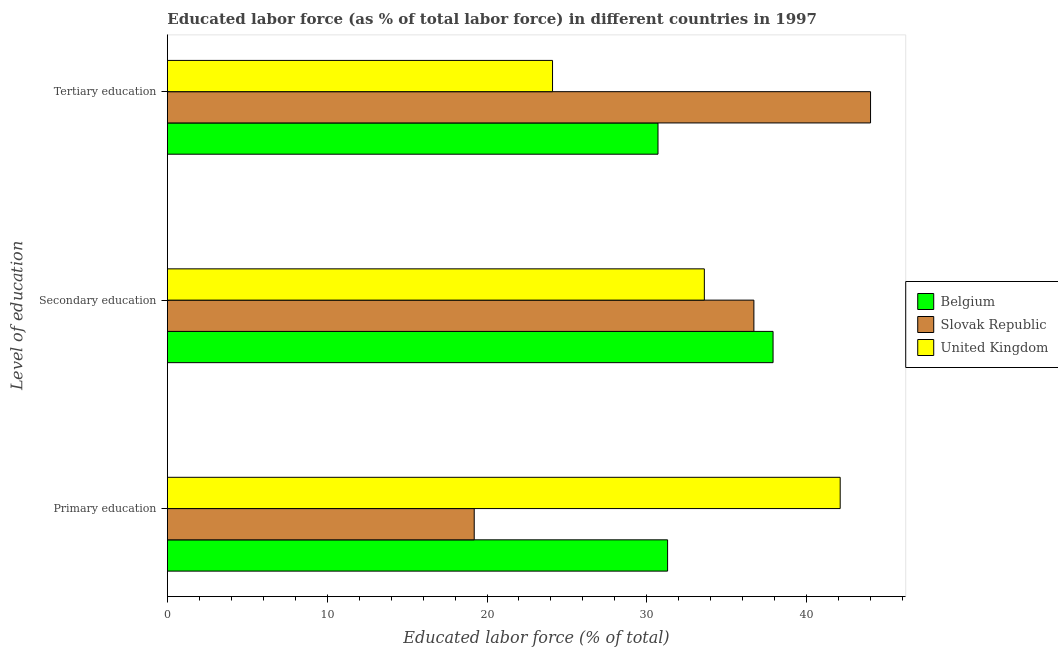Are the number of bars per tick equal to the number of legend labels?
Give a very brief answer. Yes. Are the number of bars on each tick of the Y-axis equal?
Your answer should be compact. Yes. How many bars are there on the 2nd tick from the top?
Ensure brevity in your answer.  3. How many bars are there on the 2nd tick from the bottom?
Keep it short and to the point. 3. What is the percentage of labor force who received tertiary education in Belgium?
Keep it short and to the point. 30.7. Across all countries, what is the minimum percentage of labor force who received secondary education?
Offer a very short reply. 33.6. In which country was the percentage of labor force who received tertiary education maximum?
Offer a very short reply. Slovak Republic. In which country was the percentage of labor force who received secondary education minimum?
Your answer should be compact. United Kingdom. What is the total percentage of labor force who received secondary education in the graph?
Make the answer very short. 108.2. What is the difference between the percentage of labor force who received primary education in Belgium and that in United Kingdom?
Provide a succinct answer. -10.8. What is the difference between the percentage of labor force who received primary education in Belgium and the percentage of labor force who received tertiary education in Slovak Republic?
Provide a short and direct response. -12.7. What is the average percentage of labor force who received tertiary education per country?
Provide a succinct answer. 32.93. What is the difference between the percentage of labor force who received secondary education and percentage of labor force who received tertiary education in Slovak Republic?
Your answer should be compact. -7.3. In how many countries, is the percentage of labor force who received tertiary education greater than 24 %?
Provide a short and direct response. 3. What is the ratio of the percentage of labor force who received tertiary education in United Kingdom to that in Slovak Republic?
Give a very brief answer. 0.55. Is the percentage of labor force who received tertiary education in Slovak Republic less than that in United Kingdom?
Keep it short and to the point. No. Is the difference between the percentage of labor force who received secondary education in Belgium and United Kingdom greater than the difference between the percentage of labor force who received primary education in Belgium and United Kingdom?
Keep it short and to the point. Yes. What is the difference between the highest and the second highest percentage of labor force who received primary education?
Keep it short and to the point. 10.8. What is the difference between the highest and the lowest percentage of labor force who received secondary education?
Your answer should be compact. 4.3. What does the 1st bar from the top in Primary education represents?
Give a very brief answer. United Kingdom. What does the 2nd bar from the bottom in Tertiary education represents?
Your answer should be compact. Slovak Republic. How many bars are there?
Ensure brevity in your answer.  9. Are all the bars in the graph horizontal?
Your response must be concise. Yes. How many countries are there in the graph?
Ensure brevity in your answer.  3. Are the values on the major ticks of X-axis written in scientific E-notation?
Keep it short and to the point. No. Does the graph contain grids?
Offer a terse response. No. Where does the legend appear in the graph?
Make the answer very short. Center right. What is the title of the graph?
Your response must be concise. Educated labor force (as % of total labor force) in different countries in 1997. Does "St. Lucia" appear as one of the legend labels in the graph?
Keep it short and to the point. No. What is the label or title of the X-axis?
Provide a succinct answer. Educated labor force (% of total). What is the label or title of the Y-axis?
Your response must be concise. Level of education. What is the Educated labor force (% of total) of Belgium in Primary education?
Ensure brevity in your answer.  31.3. What is the Educated labor force (% of total) of Slovak Republic in Primary education?
Ensure brevity in your answer.  19.2. What is the Educated labor force (% of total) in United Kingdom in Primary education?
Make the answer very short. 42.1. What is the Educated labor force (% of total) of Belgium in Secondary education?
Make the answer very short. 37.9. What is the Educated labor force (% of total) of Slovak Republic in Secondary education?
Keep it short and to the point. 36.7. What is the Educated labor force (% of total) of United Kingdom in Secondary education?
Make the answer very short. 33.6. What is the Educated labor force (% of total) of Belgium in Tertiary education?
Offer a terse response. 30.7. What is the Educated labor force (% of total) of Slovak Republic in Tertiary education?
Your answer should be very brief. 44. What is the Educated labor force (% of total) in United Kingdom in Tertiary education?
Ensure brevity in your answer.  24.1. Across all Level of education, what is the maximum Educated labor force (% of total) in Belgium?
Your answer should be very brief. 37.9. Across all Level of education, what is the maximum Educated labor force (% of total) of Slovak Republic?
Offer a terse response. 44. Across all Level of education, what is the maximum Educated labor force (% of total) of United Kingdom?
Provide a succinct answer. 42.1. Across all Level of education, what is the minimum Educated labor force (% of total) of Belgium?
Ensure brevity in your answer.  30.7. Across all Level of education, what is the minimum Educated labor force (% of total) of Slovak Republic?
Offer a very short reply. 19.2. Across all Level of education, what is the minimum Educated labor force (% of total) in United Kingdom?
Offer a very short reply. 24.1. What is the total Educated labor force (% of total) in Belgium in the graph?
Provide a short and direct response. 99.9. What is the total Educated labor force (% of total) of Slovak Republic in the graph?
Your answer should be compact. 99.9. What is the total Educated labor force (% of total) in United Kingdom in the graph?
Give a very brief answer. 99.8. What is the difference between the Educated labor force (% of total) in Belgium in Primary education and that in Secondary education?
Your answer should be compact. -6.6. What is the difference between the Educated labor force (% of total) of Slovak Republic in Primary education and that in Secondary education?
Offer a terse response. -17.5. What is the difference between the Educated labor force (% of total) of Belgium in Primary education and that in Tertiary education?
Your answer should be very brief. 0.6. What is the difference between the Educated labor force (% of total) of Slovak Republic in Primary education and that in Tertiary education?
Make the answer very short. -24.8. What is the difference between the Educated labor force (% of total) in Belgium in Secondary education and that in Tertiary education?
Give a very brief answer. 7.2. What is the difference between the Educated labor force (% of total) in Belgium in Primary education and the Educated labor force (% of total) in Slovak Republic in Secondary education?
Offer a terse response. -5.4. What is the difference between the Educated labor force (% of total) of Slovak Republic in Primary education and the Educated labor force (% of total) of United Kingdom in Secondary education?
Your answer should be very brief. -14.4. What is the average Educated labor force (% of total) in Belgium per Level of education?
Give a very brief answer. 33.3. What is the average Educated labor force (% of total) of Slovak Republic per Level of education?
Provide a succinct answer. 33.3. What is the average Educated labor force (% of total) in United Kingdom per Level of education?
Keep it short and to the point. 33.27. What is the difference between the Educated labor force (% of total) of Belgium and Educated labor force (% of total) of Slovak Republic in Primary education?
Your answer should be compact. 12.1. What is the difference between the Educated labor force (% of total) in Slovak Republic and Educated labor force (% of total) in United Kingdom in Primary education?
Keep it short and to the point. -22.9. What is the difference between the Educated labor force (% of total) of Belgium and Educated labor force (% of total) of United Kingdom in Secondary education?
Give a very brief answer. 4.3. What is the difference between the Educated labor force (% of total) of Belgium and Educated labor force (% of total) of United Kingdom in Tertiary education?
Offer a very short reply. 6.6. What is the difference between the Educated labor force (% of total) in Slovak Republic and Educated labor force (% of total) in United Kingdom in Tertiary education?
Your response must be concise. 19.9. What is the ratio of the Educated labor force (% of total) of Belgium in Primary education to that in Secondary education?
Your response must be concise. 0.83. What is the ratio of the Educated labor force (% of total) in Slovak Republic in Primary education to that in Secondary education?
Offer a terse response. 0.52. What is the ratio of the Educated labor force (% of total) of United Kingdom in Primary education to that in Secondary education?
Your answer should be compact. 1.25. What is the ratio of the Educated labor force (% of total) in Belgium in Primary education to that in Tertiary education?
Give a very brief answer. 1.02. What is the ratio of the Educated labor force (% of total) in Slovak Republic in Primary education to that in Tertiary education?
Offer a very short reply. 0.44. What is the ratio of the Educated labor force (% of total) in United Kingdom in Primary education to that in Tertiary education?
Offer a very short reply. 1.75. What is the ratio of the Educated labor force (% of total) of Belgium in Secondary education to that in Tertiary education?
Ensure brevity in your answer.  1.23. What is the ratio of the Educated labor force (% of total) of Slovak Republic in Secondary education to that in Tertiary education?
Your response must be concise. 0.83. What is the ratio of the Educated labor force (% of total) of United Kingdom in Secondary education to that in Tertiary education?
Provide a succinct answer. 1.39. What is the difference between the highest and the lowest Educated labor force (% of total) in Belgium?
Give a very brief answer. 7.2. What is the difference between the highest and the lowest Educated labor force (% of total) of Slovak Republic?
Offer a terse response. 24.8. What is the difference between the highest and the lowest Educated labor force (% of total) in United Kingdom?
Provide a succinct answer. 18. 